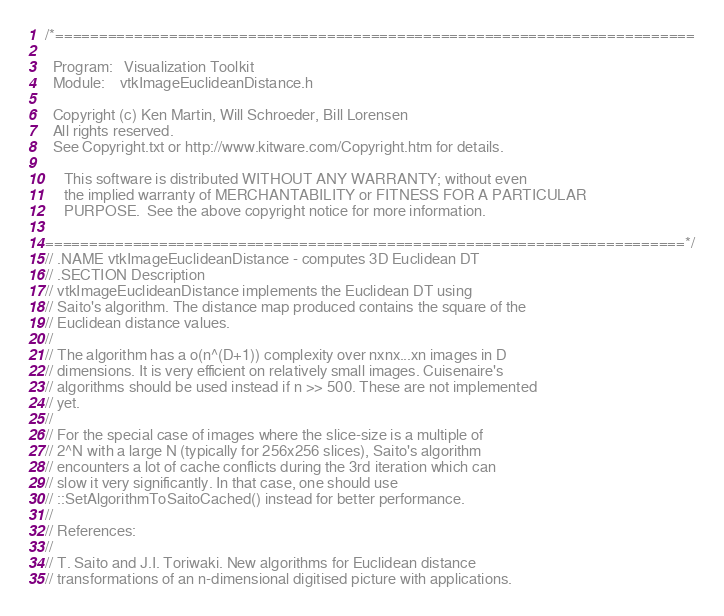<code> <loc_0><loc_0><loc_500><loc_500><_C_>/*=========================================================================

  Program:   Visualization Toolkit
  Module:    vtkImageEuclideanDistance.h

  Copyright (c) Ken Martin, Will Schroeder, Bill Lorensen
  All rights reserved.
  See Copyright.txt or http://www.kitware.com/Copyright.htm for details.

     This software is distributed WITHOUT ANY WARRANTY; without even
     the implied warranty of MERCHANTABILITY or FITNESS FOR A PARTICULAR
     PURPOSE.  See the above copyright notice for more information.

=========================================================================*/
// .NAME vtkImageEuclideanDistance - computes 3D Euclidean DT 
// .SECTION Description
// vtkImageEuclideanDistance implements the Euclidean DT using
// Saito's algorithm. The distance map produced contains the square of the
// Euclidean distance values. 
//
// The algorithm has a o(n^(D+1)) complexity over nxnx...xn images in D 
// dimensions. It is very efficient on relatively small images. Cuisenaire's
// algorithms should be used instead if n >> 500. These are not implemented
// yet.
//
// For the special case of images where the slice-size is a multiple of 
// 2^N with a large N (typically for 256x256 slices), Saito's algorithm 
// encounters a lot of cache conflicts during the 3rd iteration which can 
// slow it very significantly. In that case, one should use 
// ::SetAlgorithmToSaitoCached() instead for better performance. 
//
// References:
//
// T. Saito and J.I. Toriwaki. New algorithms for Euclidean distance 
// transformations of an n-dimensional digitised picture with applications.</code> 